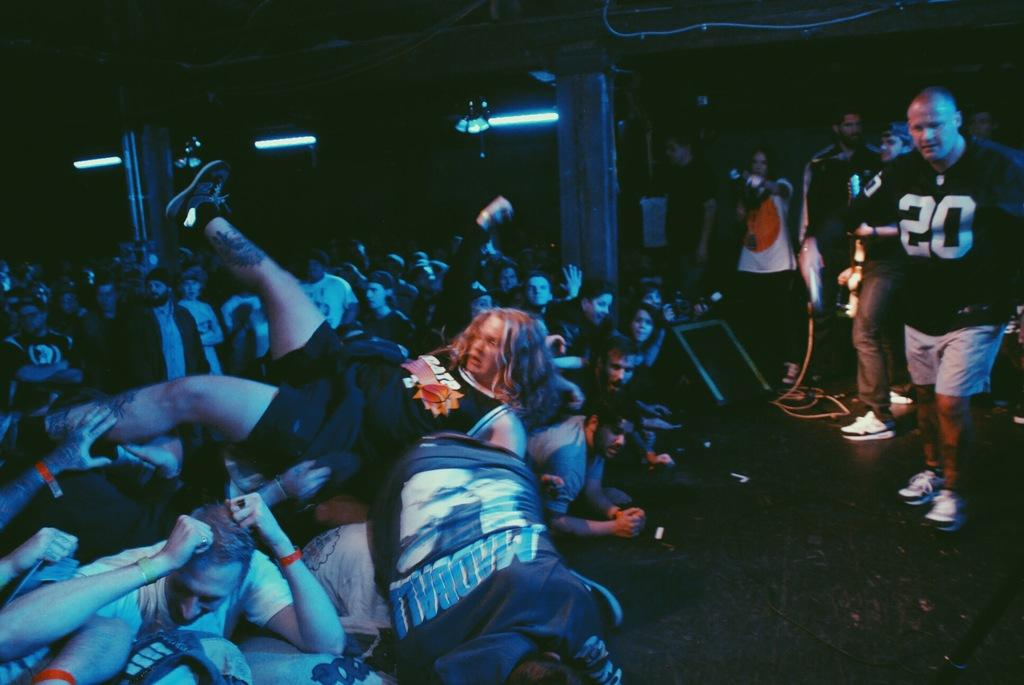<image>
Render a clear and concise summary of the photo. The man in the black jersey has the number 20 on the front 